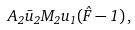<formula> <loc_0><loc_0><loc_500><loc_500>A _ { 2 } \bar { u } _ { 2 } M _ { 2 } u _ { 1 } ( \hat { F } - 1 ) \, ,</formula> 